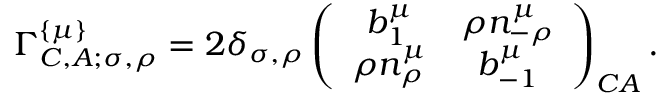<formula> <loc_0><loc_0><loc_500><loc_500>\Gamma _ { C , A ; \sigma , \rho } ^ { \left \{ \mu \right \} } = 2 \delta _ { \sigma , \rho } \left ( \begin{array} { c c } { { b _ { 1 } ^ { \mu } } } & { { \rho n _ { - \rho } ^ { \mu } } } \\ { { \rho n _ { \rho } ^ { \mu } } } & { { b _ { - 1 } ^ { \mu } } } \end{array} \right ) _ { C A } .</formula> 